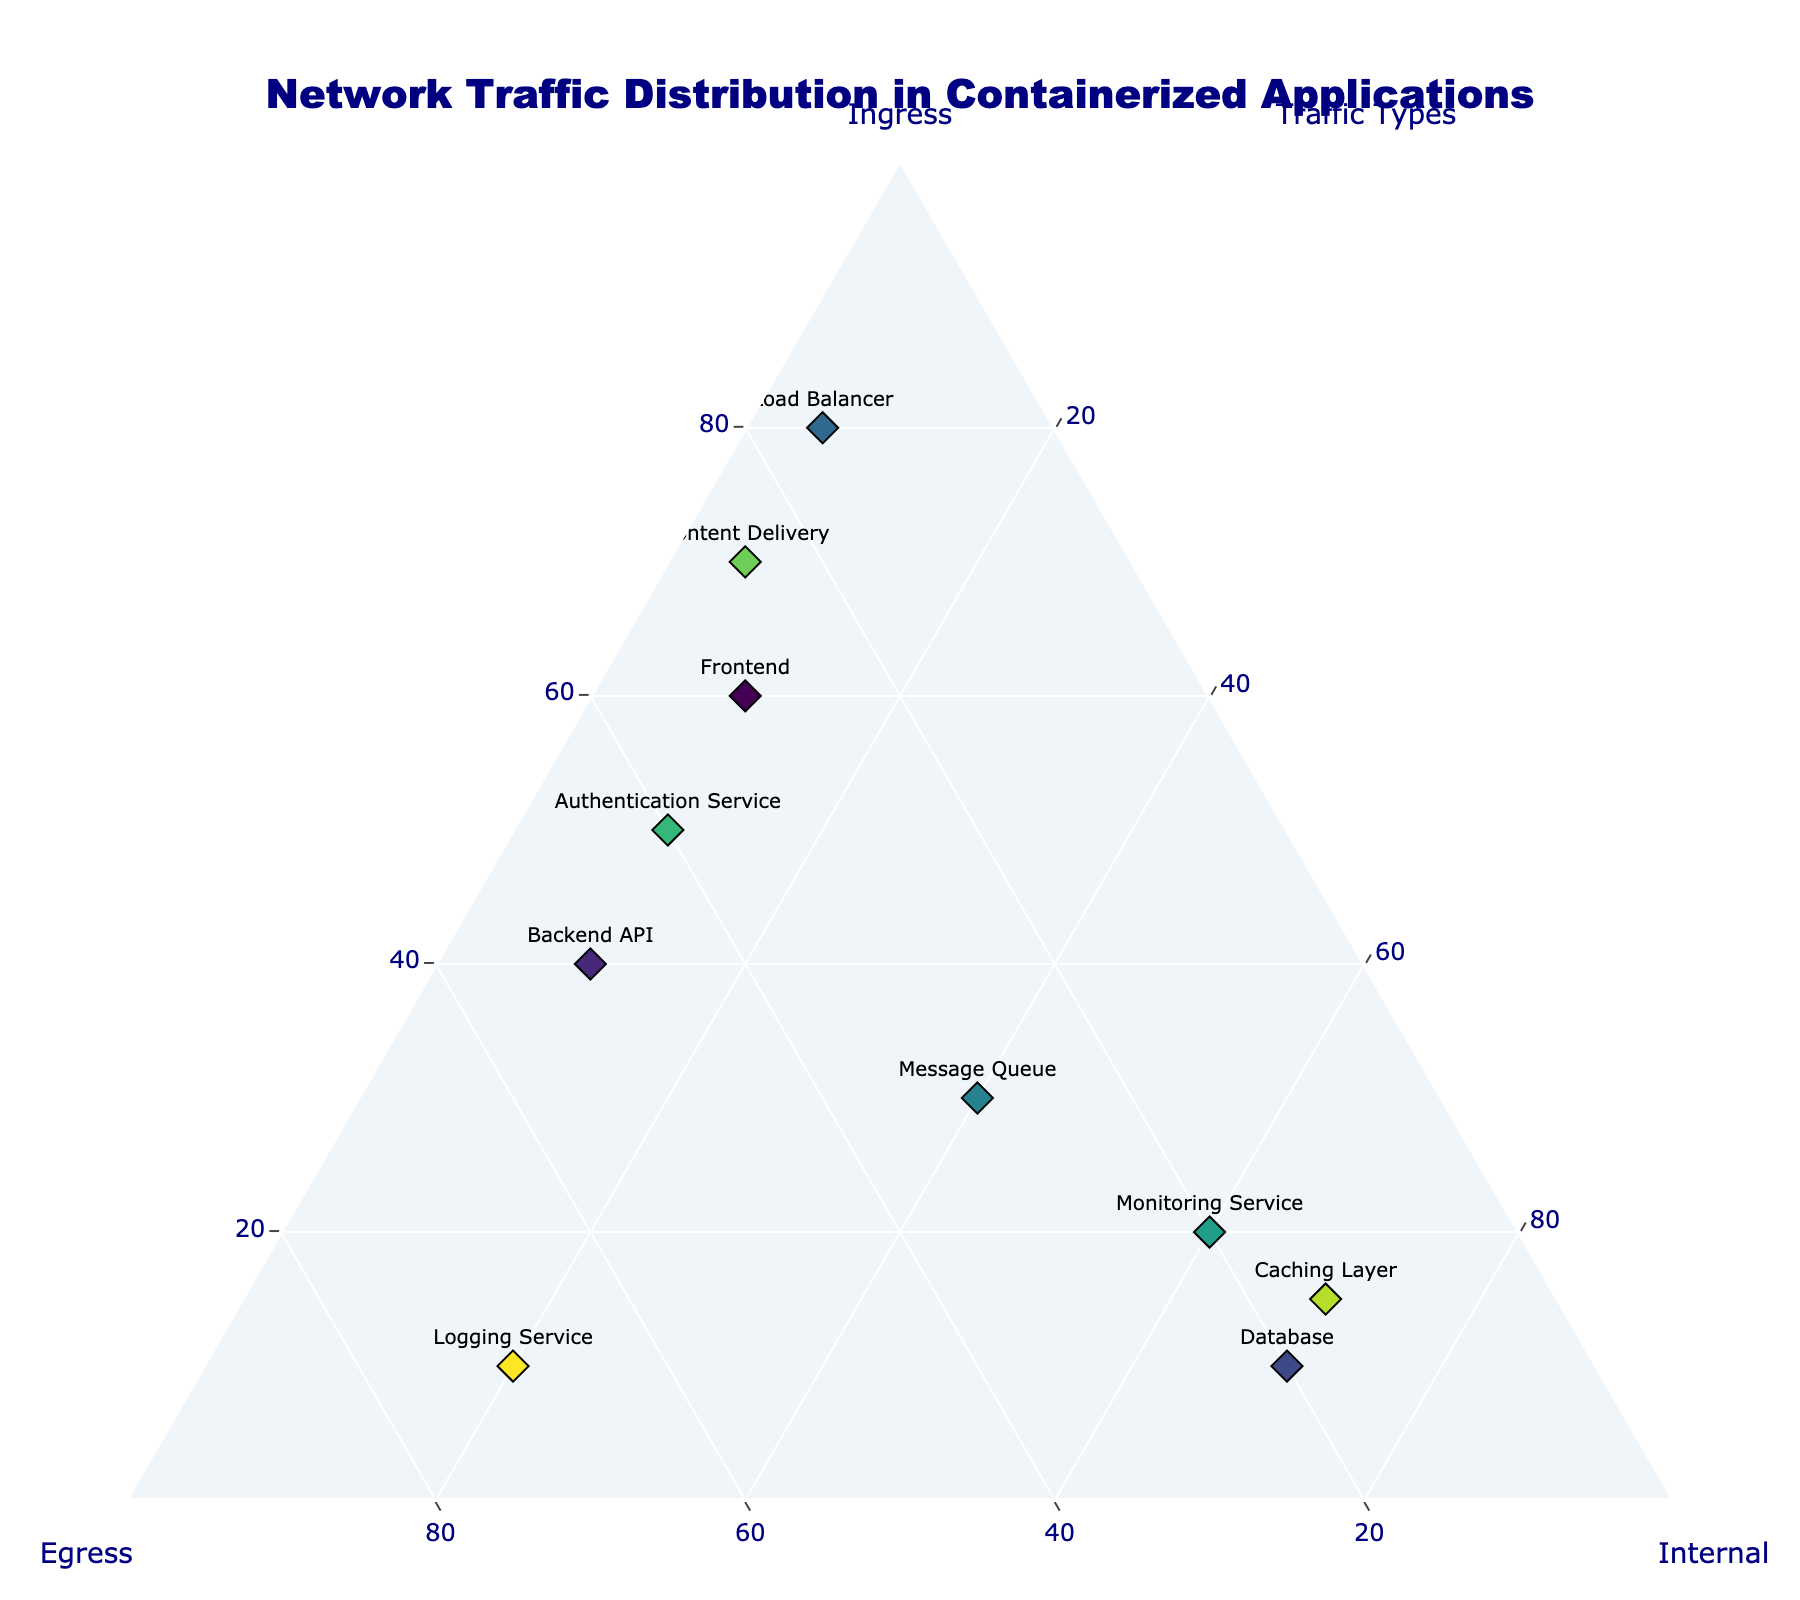what's the title of the figure? The title is located at the top of the figure and typically describes the content or purpose of the visualization.
Answer: Network Traffic Distribution in Containerized Applications how many data points are represented in the figure? The number of data points can be counted by identifying the unique markers or labels for different applications. In this case, each application represents a data point.
Answer: 10 which application has the highest ingress traffic? By comparing the values along the Ingress axis, the application with the highest value will have the highest ingress traffic.
Answer: Load Balancer which application’s network traffic is equally distributed among ingress, egress, and internal types? By looking for an application whose marker is closest to the center of the ternary plot, where ingress, egress, and internal are equal (33.3%, 33.3%, 33.3%).
Answer: Message Queue what's the difference in the internal traffic between the Database and the Caching Layer? Identify the internal traffic values for both the Database and the Caching Layer from the plot. Subtract one from the other to find the difference.
Answer: 0 which application has the least egress traffic? By comparing the values along the Egress axis, the application with the lowest value will have the least egress traffic.
Answer: Load Balancer how does the internal traffic of the Monitoring Service compare to that of the Logging Service? Compare the values of internal traffic for Monitoring Service and Logging Service by locating their markers on the ternary plot.
Answer: Monitoring Service has more internal traffic than Logging Service what's the average of the ingress traffic for Frontend, Load Balancer, and Content Delivery? Sum the ingress values for Frontend, Load Balancer, and Content Delivery, then divide by 3 to find the average.
Answer: 70 which application has the closest egress and internal traffic values? Compare the egress and internal traffic values for each application to find the one with the smallest difference between the two.
Answer: Logging Service if you sum the internal traffic for all applications, what is the total? Sum up the internal traffic values for all applications represented in the figure.
Answer: 355 